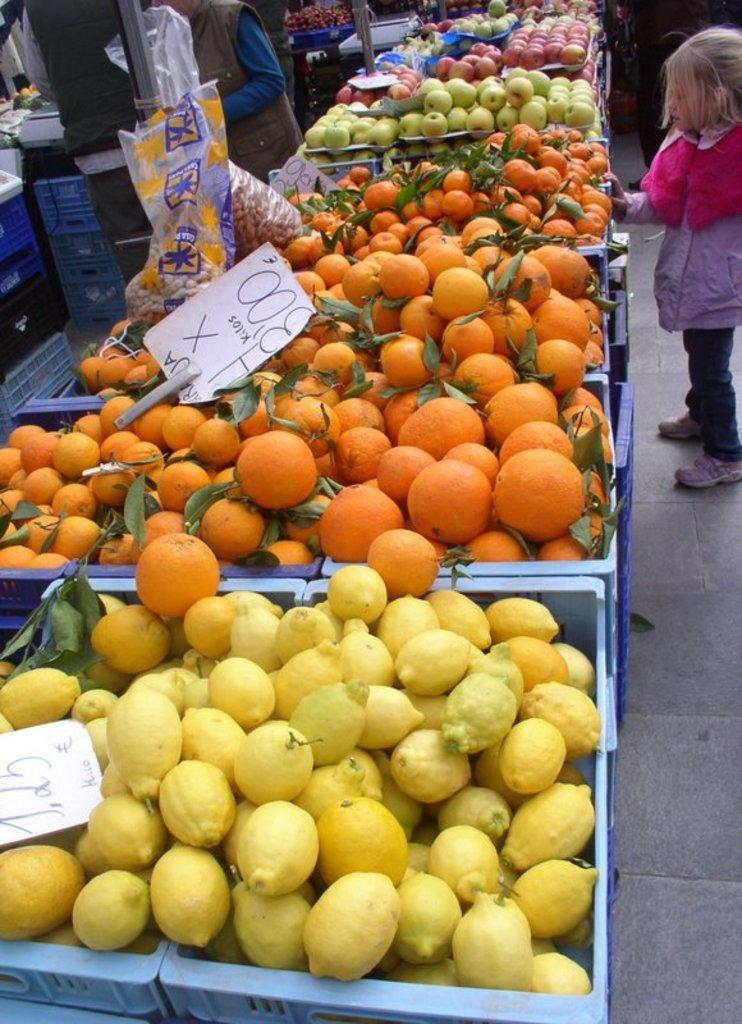What is in the tray that is visible in the image? There are fruits in a tray in the image. How many people are in the image? There are two persons standing in the image. Can you describe the possible location of the image? The image may have been taken in a market. What time of day might the image have been taken? The image may have been taken during the day. Who is the owner of the curtain in the image? There is no curtain present in the image, so it is not possible to determine the owner. 